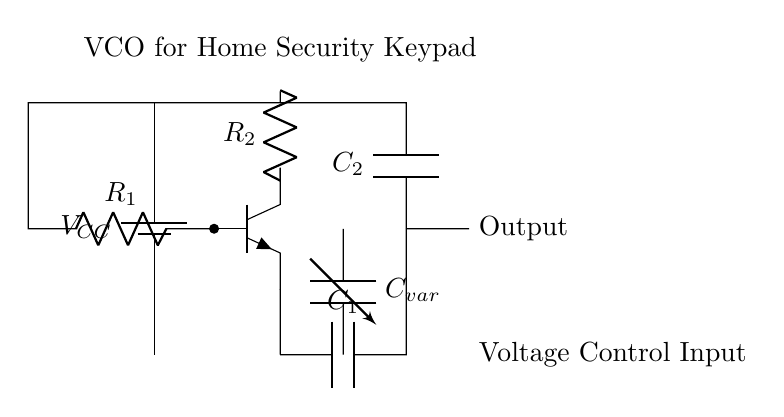What is the power supply voltage in this circuit? The power supply voltage is represented by the label $V_{CC}$, which typically indicates a positive voltage source for the circuit components.
Answer: VCC What type of transistor is used in this circuit? The transistor shown is an NPN transistor, identifiable by the configuration of the connections and the labeling on the diagram.
Answer: NPN How many resistors are in the circuit? The circuit diagram displays two resistors, labeled R1 and R2, which are in series connection with the NPN transistor.
Answer: 2 What is the role of the variable capacitor? The variable capacitor, labeled C_var, allows for tuning the frequency of the oscillator by adjusting its capacitance, thus controlling the oscillation based on voltage changes.
Answer: Tuning What is the total voltage across the capacitor connected to the collector of the transistor? The voltage across the capacitor connected to the collector (C2) is $V_{CC}$, as it receives the full supply voltage when the circuit is operational, due to the direct connection to the power supply.
Answer: VCC How does the output signal relate to the input voltage? The output signal fluctuates based on the controlled voltage input, which adjusts the capacitance of the variable capacitor, leading to a corresponding change in frequency and thus modulation of the output signal.
Answer: Modulated 